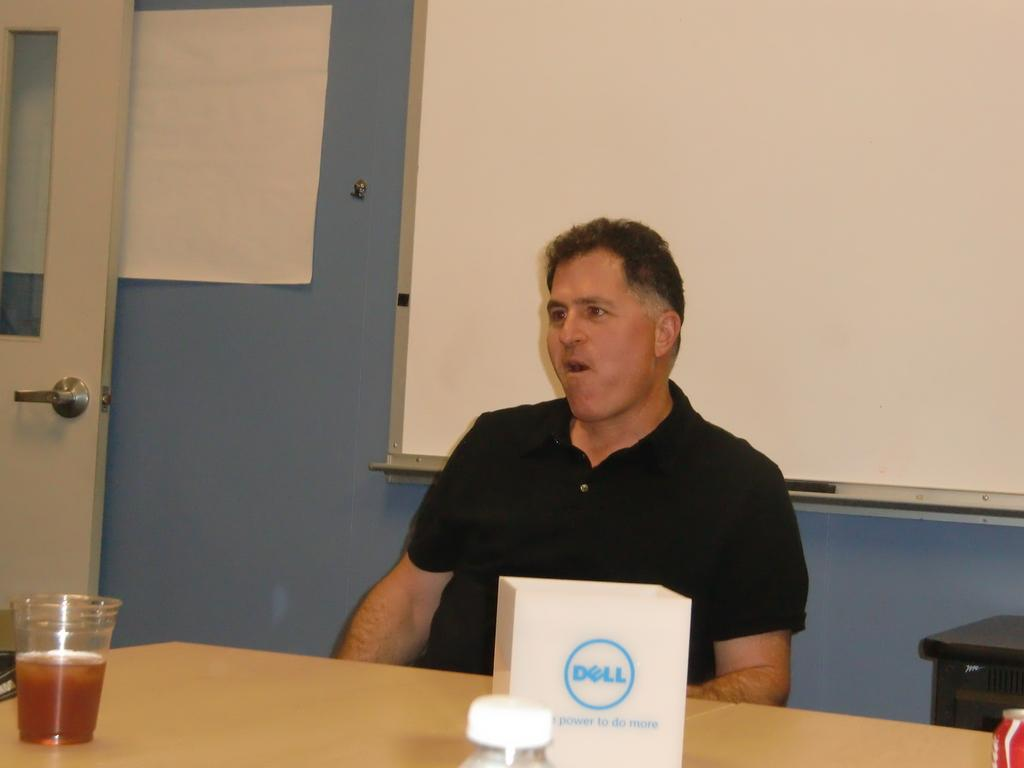What is the man in the image doing? The man is sitting on a chair in the image. What can be seen on the table in the image? There is a glass with liquid, a bottle, and a packet on the table in the image. What is hanging on the wall in the image? There is a banner on the wall in the image. What feature is present on the door in the image? The door has a handle in the image. How many wrens are perched on the man's shoulder in the image? There are no wrens present in the image. What type of eggnog is being served in the glass with liquid in the image? There is no eggnog present in the image; it is a glass with liquid, but the specific type of liquid is not mentioned. 